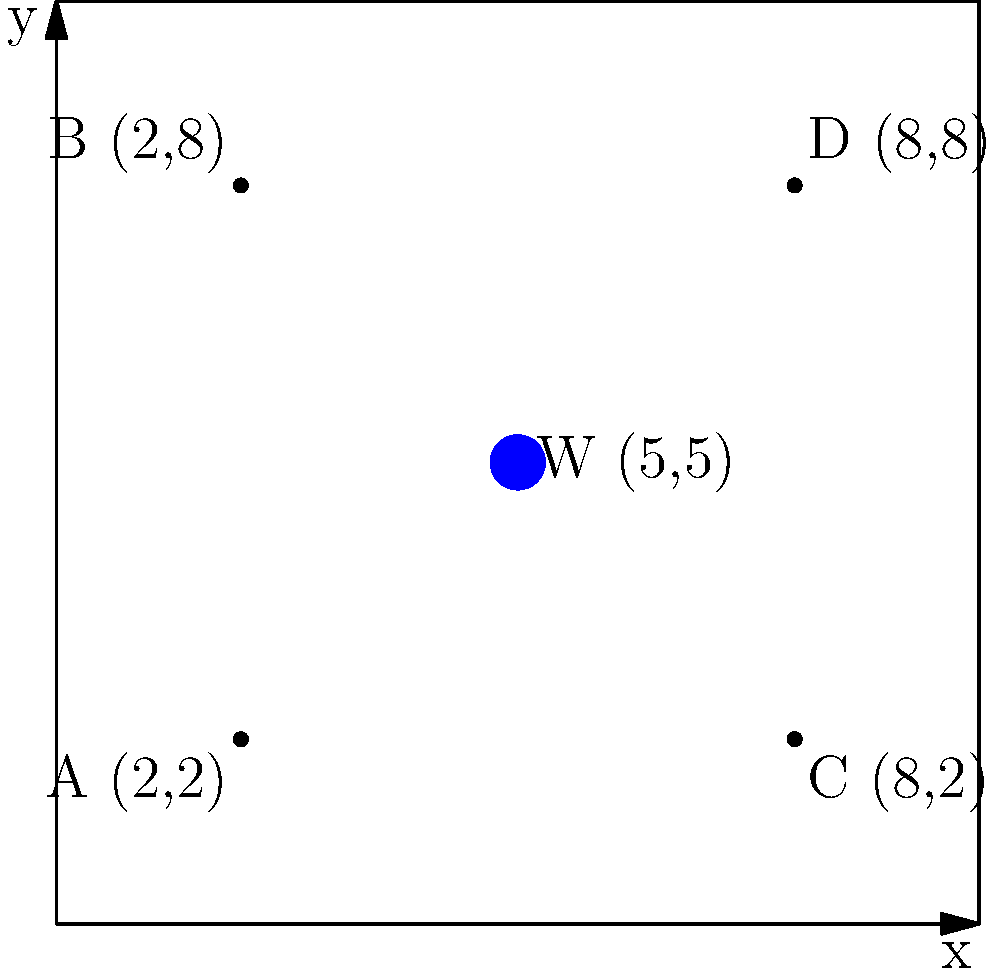In a square garden plot measuring 10 meters by 10 meters, you want to set up a drip irrigation system. Four plants are located at points A(2,2), B(2,8), C(8,2), and D(8,8). The water source is at point W(5,5). To minimize water usage, you need to calculate the total length of piping required to connect the water source to all four plants in the most efficient way. What is the minimum total length of piping needed, rounded to the nearest tenth of a meter? To solve this problem, we'll use the concept of the minimum spanning tree, specifically the star configuration, since we have a central water source.

Step 1: Calculate the distance from the water source W to each plant using the distance formula:
$d = \sqrt{(x_2-x_1)^2 + (y_2-y_1)^2}$

For WA: $d_{WA} = \sqrt{(5-2)^2 + (5-2)^2} = \sqrt{18} = 3\sqrt{2}$
For WB: $d_{WB} = \sqrt{(5-2)^2 + (5-8)^2} = \sqrt{18} = 3\sqrt{2}$
For WC: $d_{WC} = \sqrt{(5-8)^2 + (5-2)^2} = \sqrt{18} = 3\sqrt{2}$
For WD: $d_{WD} = \sqrt{(5-8)^2 + (5-8)^2} = \sqrt{18} = 3\sqrt{2}$

Step 2: Sum up all the distances to get the total length of piping needed:
Total length = $d_{WA} + d_{WB} + d_{WC} + d_{WD}$
$= 3\sqrt{2} + 3\sqrt{2} + 3\sqrt{2} + 3\sqrt{2}$
$= 12\sqrt{2}$

Step 3: Convert $12\sqrt{2}$ to a decimal and round to the nearest tenth:
$12\sqrt{2} \approx 16.97082859$

Rounding to the nearest tenth: 17.0 meters

Therefore, the minimum total length of piping needed is 17.0 meters.
Answer: 17.0 meters 